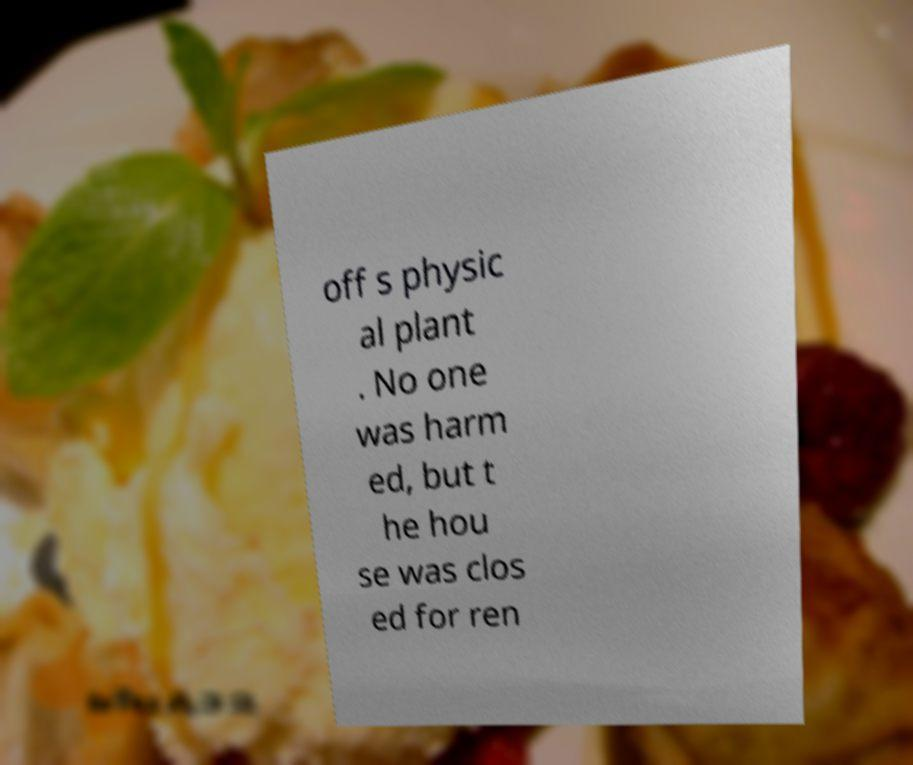There's text embedded in this image that I need extracted. Can you transcribe it verbatim? off s physic al plant . No one was harm ed, but t he hou se was clos ed for ren 